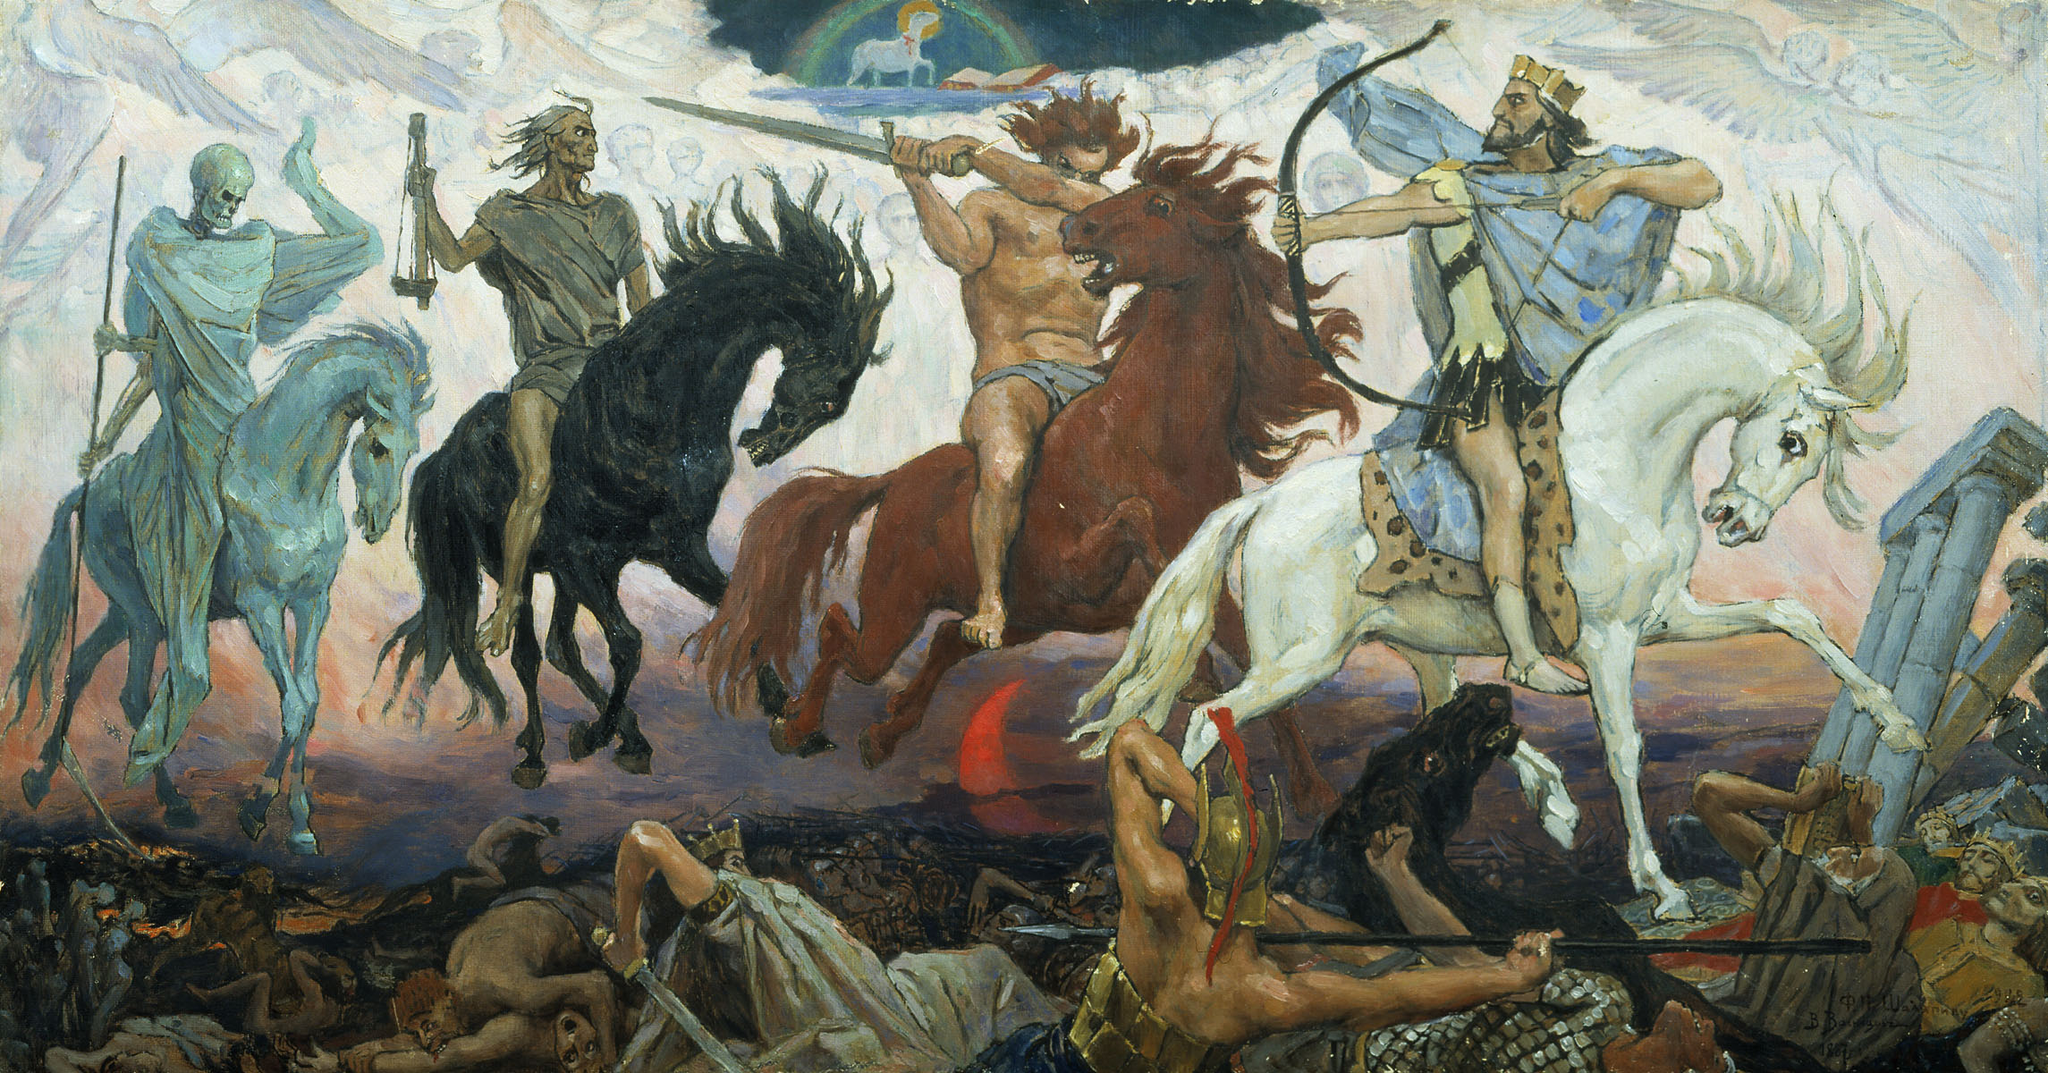What historical or cultural significance does this image have? This image captures the Four Horsemen of the Apocalypse, a symbolic representation from the Christian biblical text, the Book of Revelation. Each horseman—identified as Conquest, War, Famine, and Death—brings a specific type of destruction to humanity, symbolizing the end times and the judgment day. This theme has been widely depicted in art, literature, and even popular culture, underscoring its profound impact on Western cultural and religious thought. Why do you think artists are drawn to such apocalyptic themes? Artists are often drawn to apocalyptic themes because they evoke powerful emotions and allow for dramatic, evocative compositions. These themes address fundamental human concerns about mortality, spirituality, and the ultimate fate of humanity, providing rich material for artistic exploration. The dramatic tension and stark contrasts inherent in apocalyptic imagery can also showcase an artist’s skill in conveying complex ideas and emotions visually. 